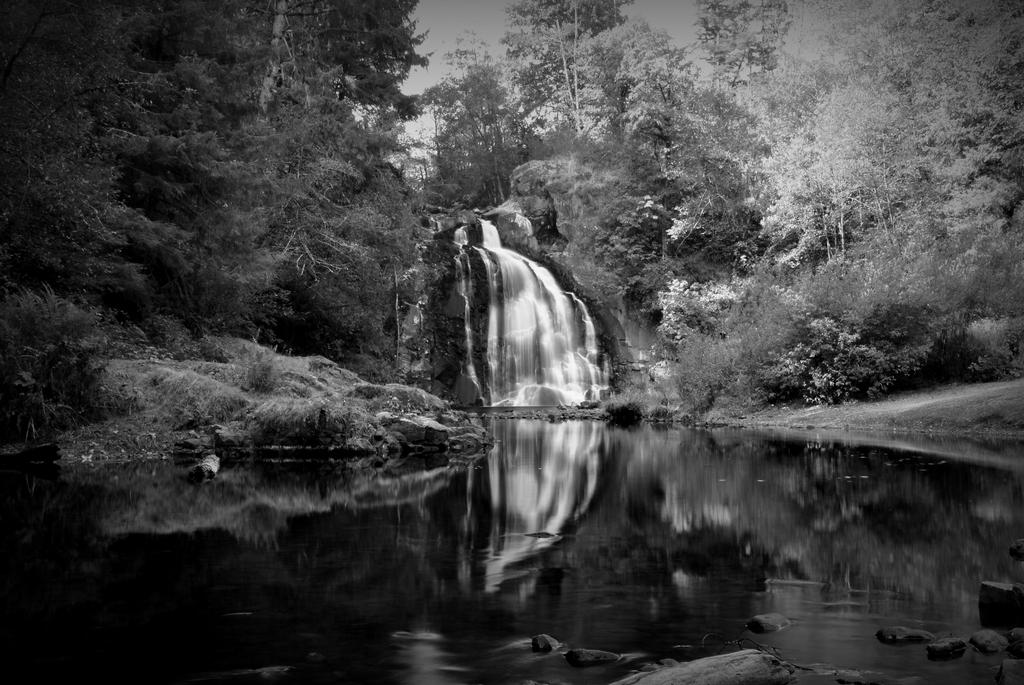What is the color scheme of the image? The image is black and white. What natural feature can be seen in the image? There is a waterfall in the image. What type of vegetation is near the waterfall? There are trees beside the waterfall. What is the primary substance visible in the image? Water is visible in the image. Can you tell me the position of the friend in the image? There is no friend present in the image; it features a black and white scene with a waterfall and trees. What type of wheel can be seen in the image? There is no wheel present in the image; it features a black and white scene with a waterfall and trees. 